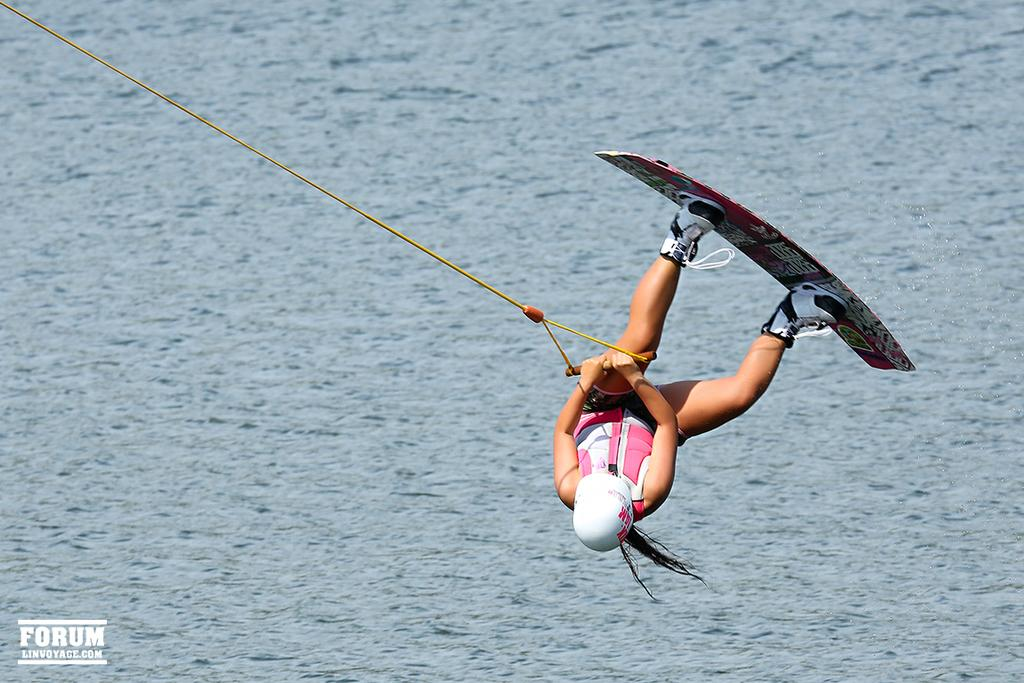Who is present in the image? There is a person in the image. What is the person holding in the image? The person is holding a rope. What is the person wearing on their feet? The person has a surfboard on their shoes. Where is the person located in the image? The person is in the air above the water. What type of fork is the person using to cook in the image? There is no fork or cooking activity present in the image. What color is the paint on the person's surfboard in the image? There is no paint or mention of color on the person's surfboard in the image. 